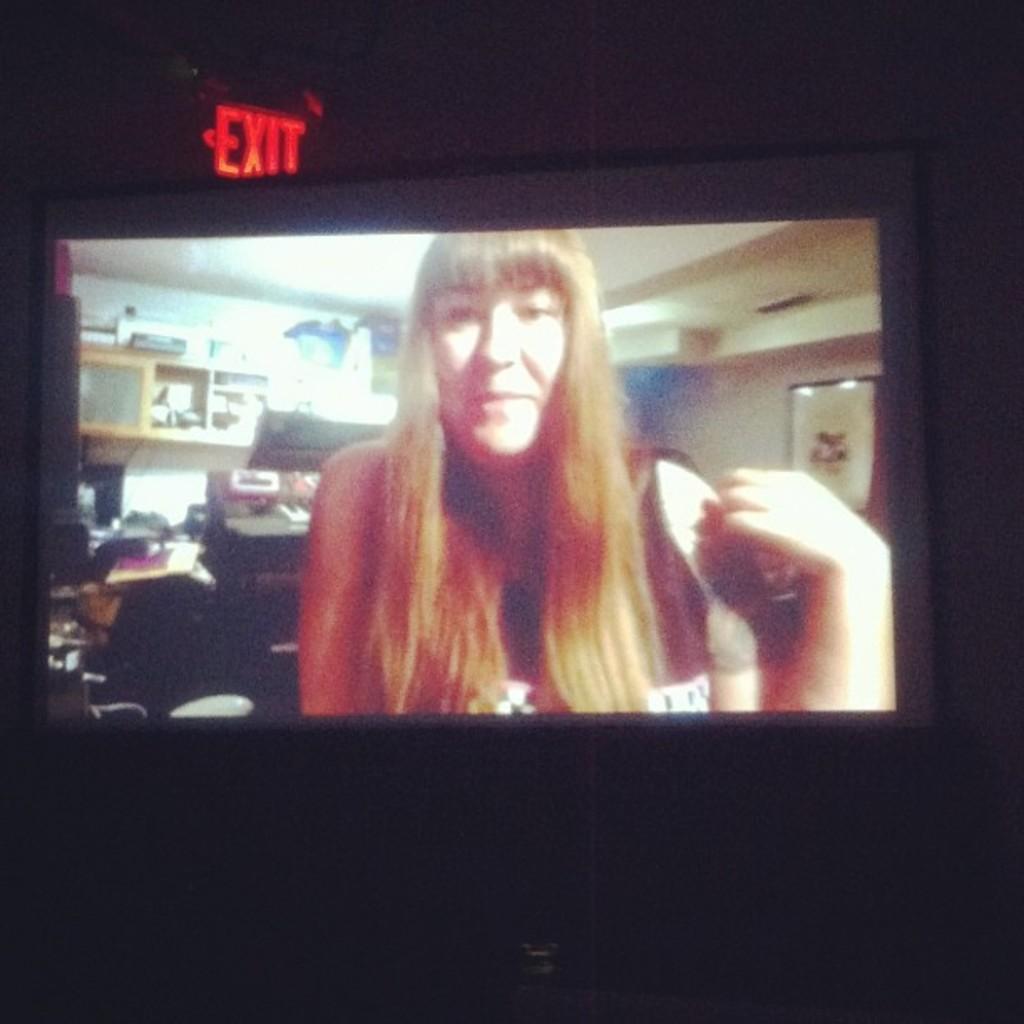What does the glowing red sign say in the back?
Your answer should be compact. Exit. 